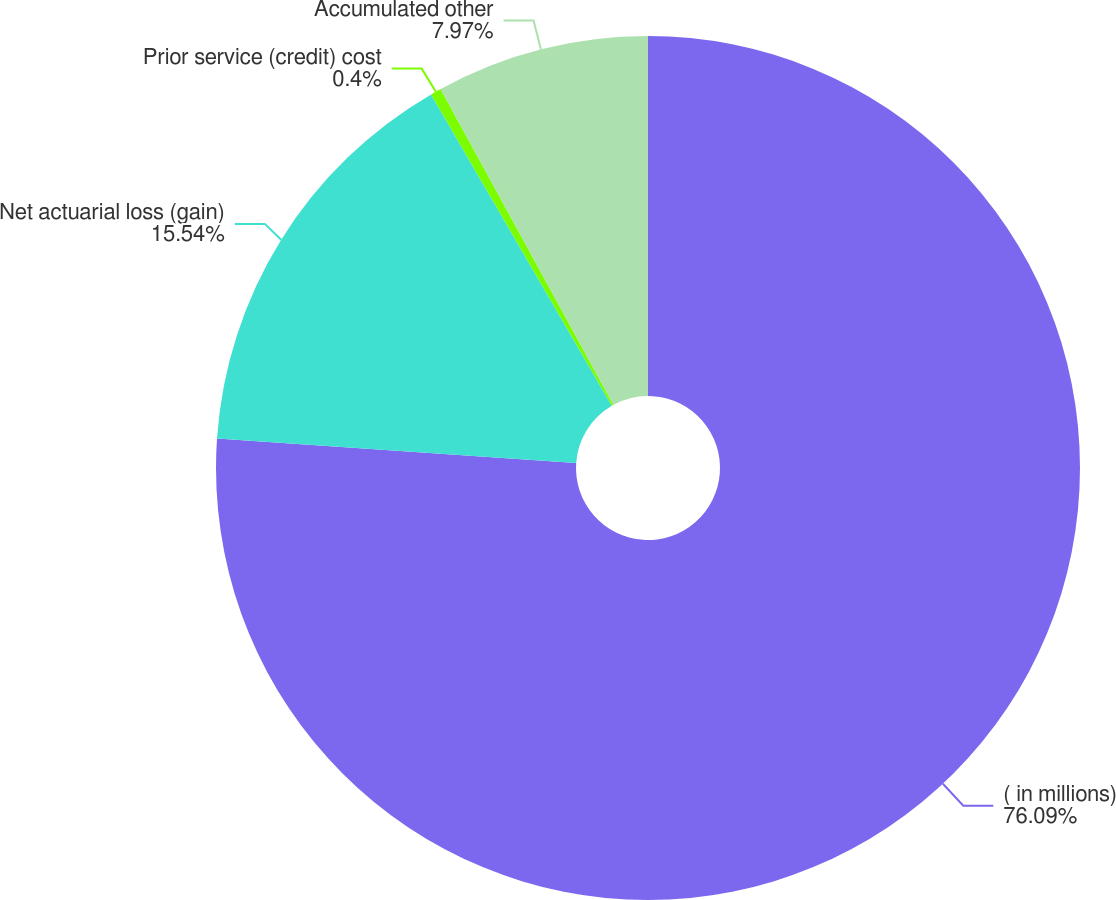<chart> <loc_0><loc_0><loc_500><loc_500><pie_chart><fcel>( in millions)<fcel>Net actuarial loss (gain)<fcel>Prior service (credit) cost<fcel>Accumulated other<nl><fcel>76.09%<fcel>15.54%<fcel>0.4%<fcel>7.97%<nl></chart> 